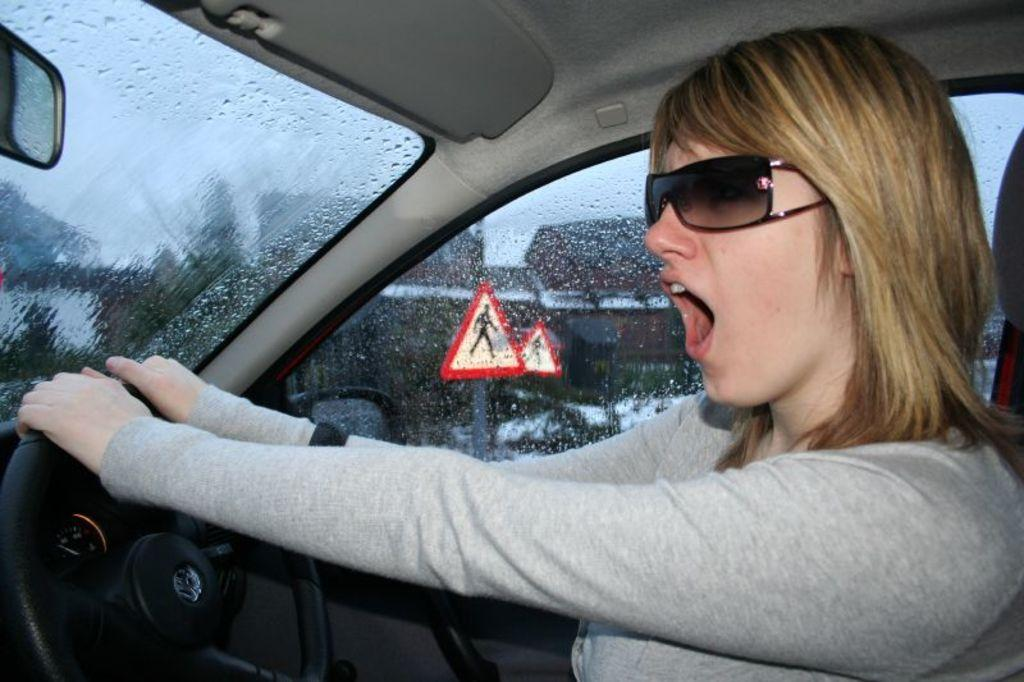What is the person in the image doing? There is a person sitting in a vehicle. What can be seen through the glass window in the vehicle? Signboards, buildings, and other vehicles are visible through the glass window. What is present inside the vehicle? There is a steering wheel and a mirror in the vehicle. What type of pies can be seen in the vehicle's glove compartment? There is no mention of pies or a glove compartment in the image, so it cannot be determined if any pies are present. --- Facts: 1. There is a person holding a book. 2. The book has a blue cover. 3. The person is sitting on a chair. 4. There is a table next to the chair. 5. A lamp is on the table. 6. The room has a wooden floor. Absurd Topics: elephant, ocean, parachute Conversation: What is the person holding in the image? The person is holding a book. What can be said about the book's appearance? The book has a blue cover. Where is the person sitting in the image? The person is sitting on a chair. What is located next to the chair? There is a table next to the chair. What is on the table? A lamp is on the table. What type of flooring is present in the room? The room has a wooden floor. Reasoning: Let's think step by step in order to produce the conversation. We start by identifying the main subject in the image, which is the person holding a book. Then, we describe the appearance of the book, noting its blue cover. Next, we mention the person's location, which is sitting on a chair. We then describe the table and lamp, which provide context for the person's surroundings. Finally, we mention the wooden floor, which is a detail about the room's design. Absurd Question/Answer: Can you see an elephant swimming in the ocean in the image? There is no mention of an elephant or an ocean in the image. 